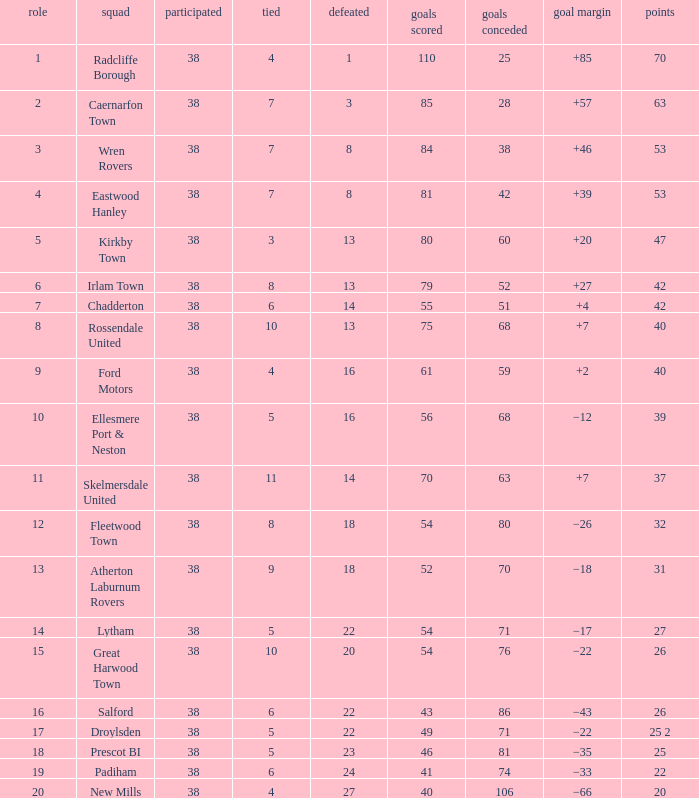How much Drawn has Goals Against of 81, and a Lost larger than 23? 0.0. 